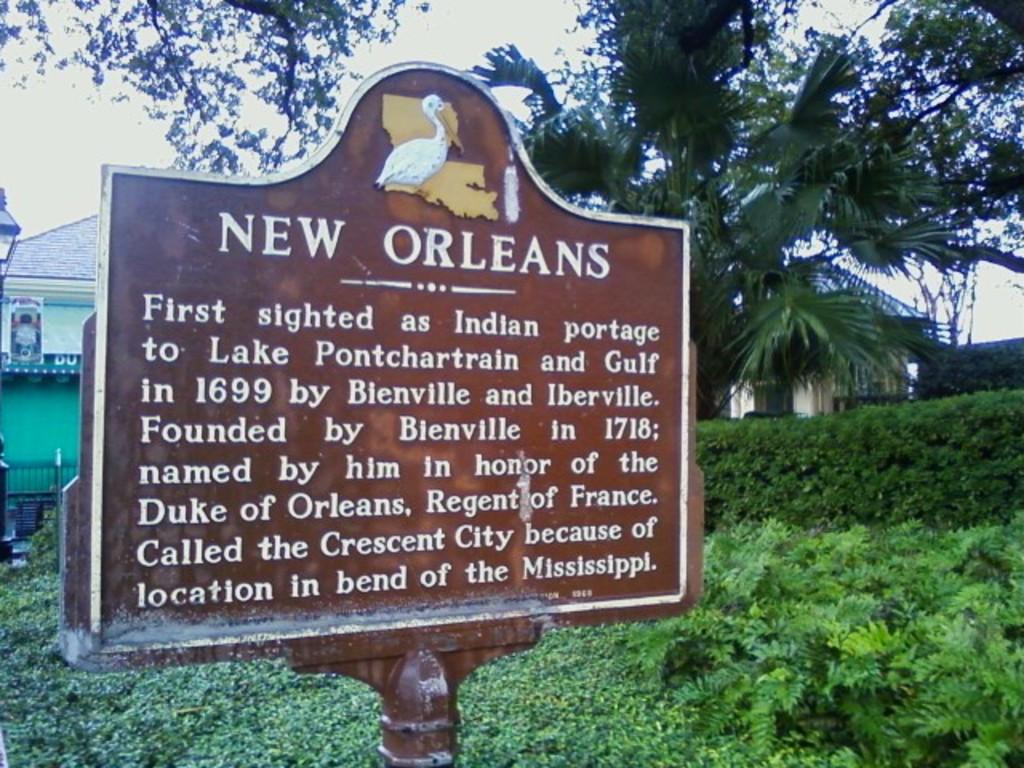Could you give a brief overview of what you see in this image? This image consists of a board in brown color. In the background, there are small plants and trees along with a house. At the top, there is a sky. 